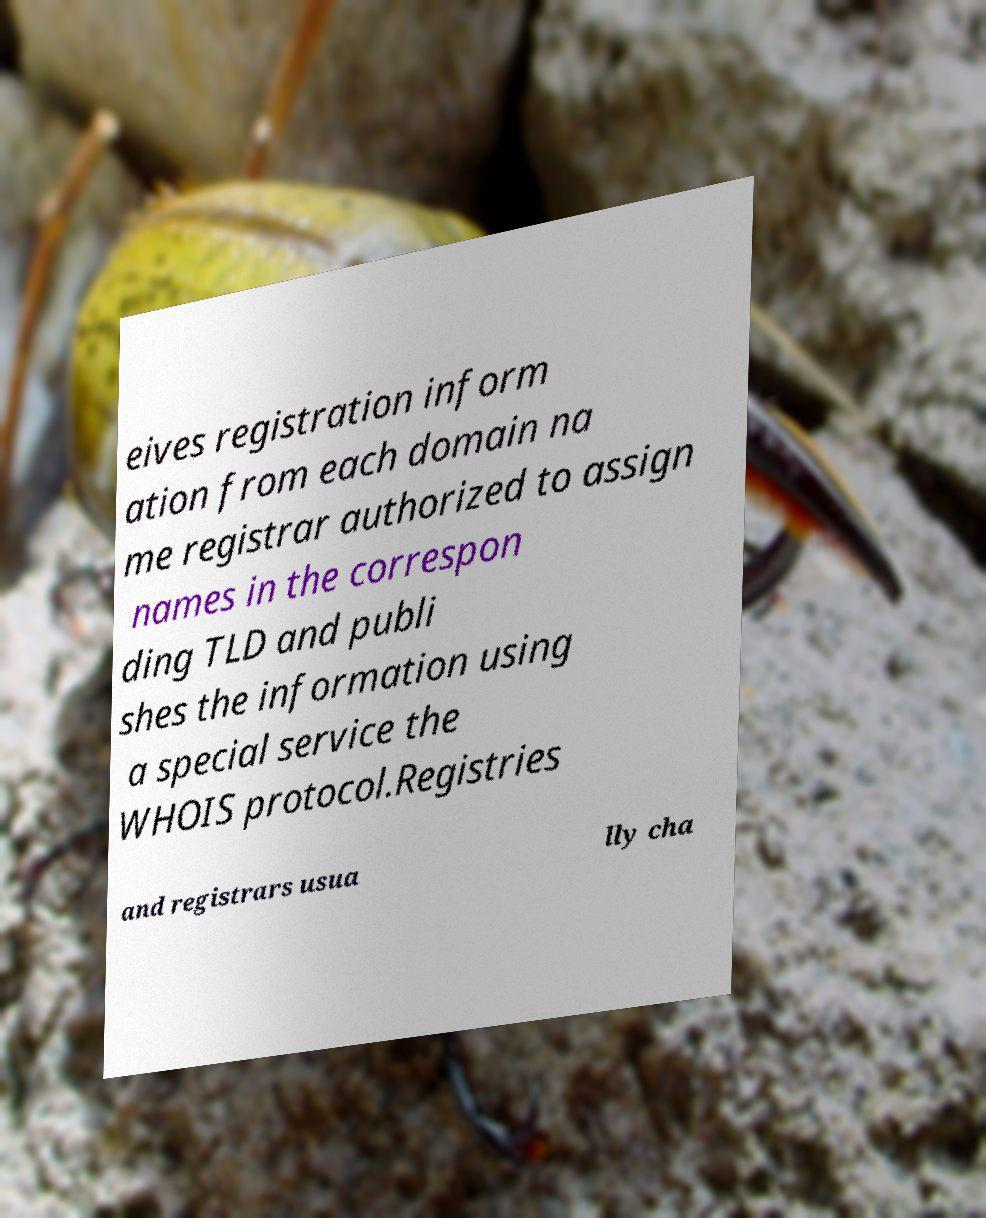Could you extract and type out the text from this image? eives registration inform ation from each domain na me registrar authorized to assign names in the correspon ding TLD and publi shes the information using a special service the WHOIS protocol.Registries and registrars usua lly cha 